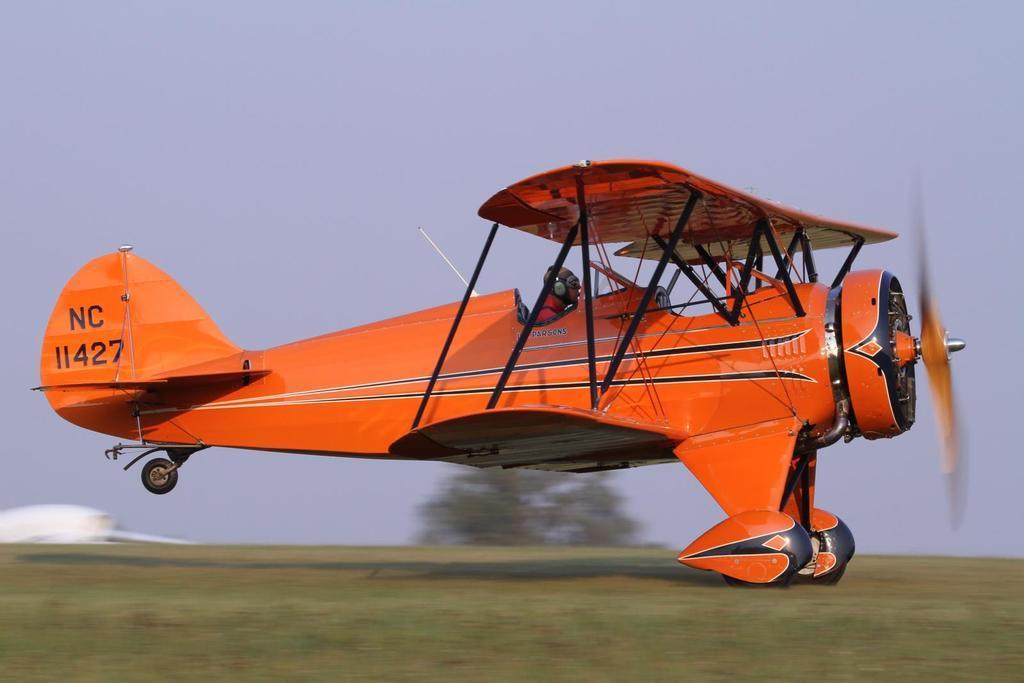In one or two sentences, can you explain what this image depicts? In this image I can see an aircraft which is in orange color and I can also see a person sitting in the aircraft. Background I can see a tree in green color and sky in white and blue color. 